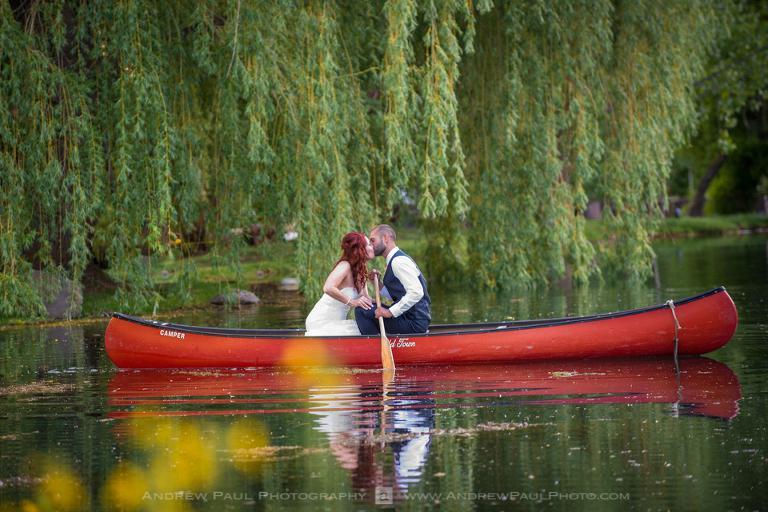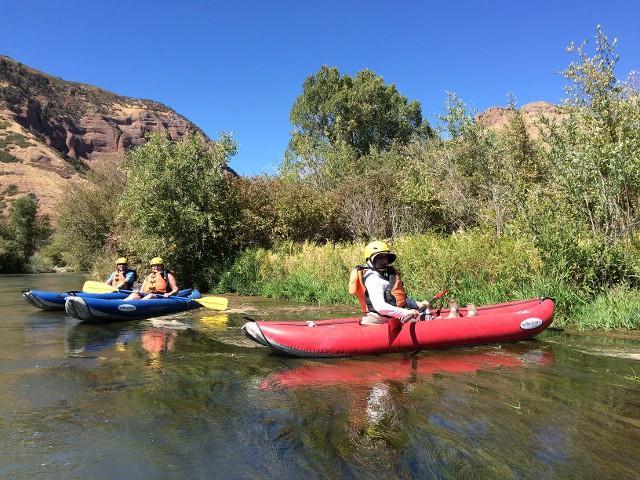The first image is the image on the left, the second image is the image on the right. For the images shown, is this caption "The left image contains at least one canoe with multiple people in it heading forward on the water." true? Answer yes or no. No. The first image is the image on the left, the second image is the image on the right. For the images displayed, is the sentence "in at least one image there are two people sitting on a boat." factually correct? Answer yes or no. Yes. 